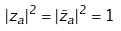<formula> <loc_0><loc_0><loc_500><loc_500>| z _ { a } | ^ { 2 } = | \tilde { z } _ { a } | ^ { 2 } = 1</formula> 